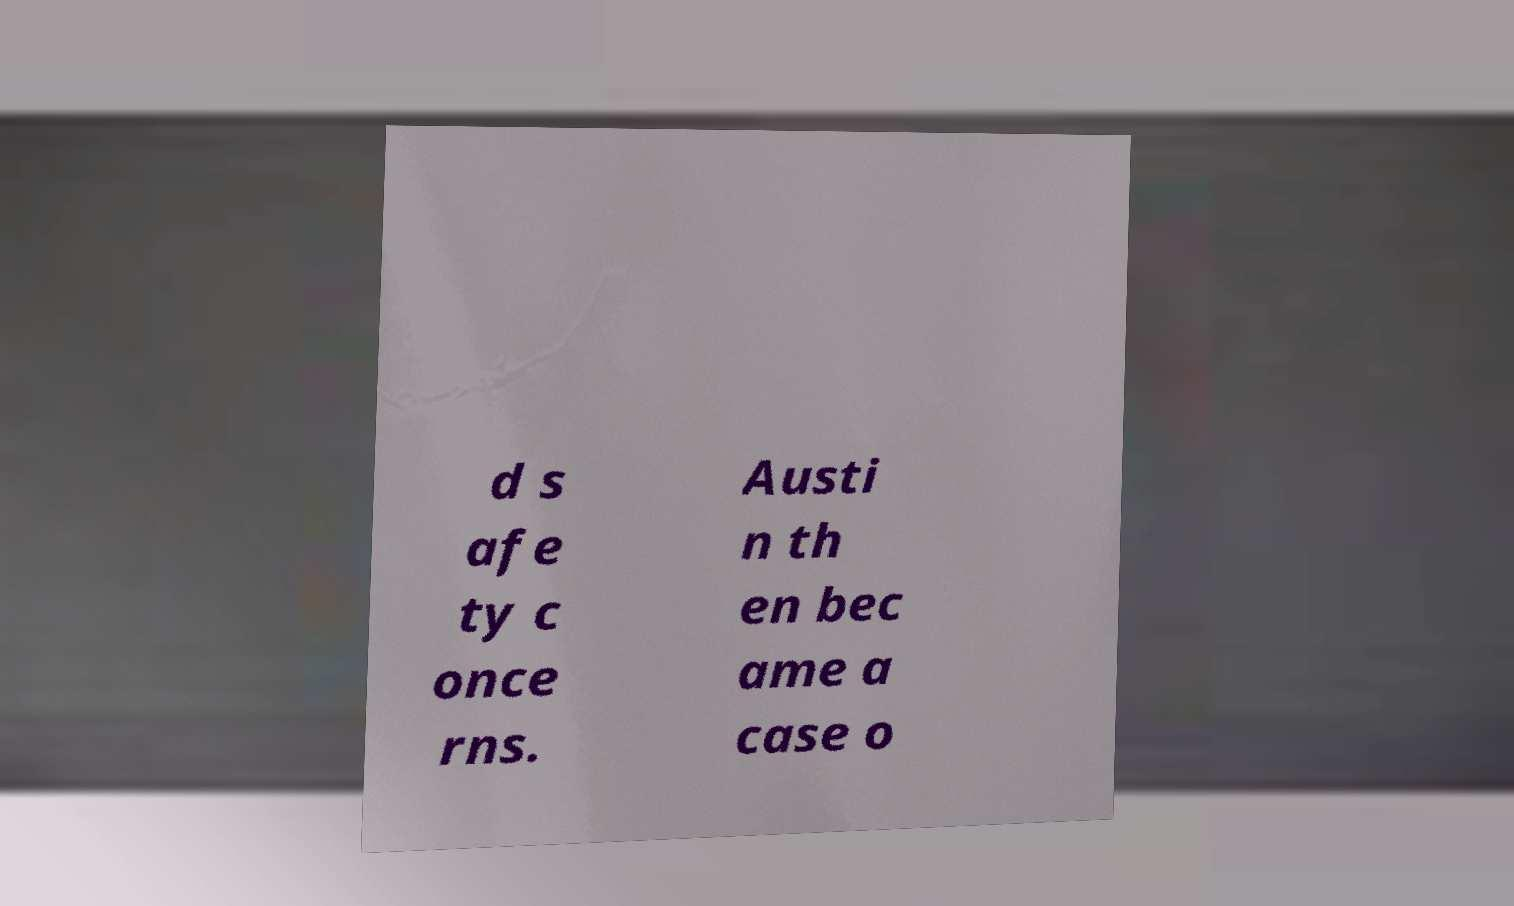I need the written content from this picture converted into text. Can you do that? d s afe ty c once rns. Austi n th en bec ame a case o 